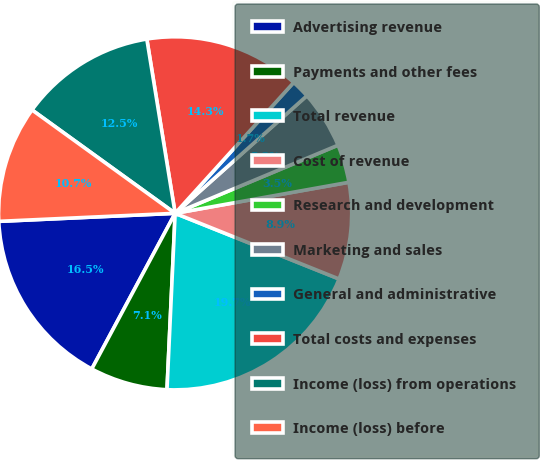<chart> <loc_0><loc_0><loc_500><loc_500><pie_chart><fcel>Advertising revenue<fcel>Payments and other fees<fcel>Total revenue<fcel>Cost of revenue<fcel>Research and development<fcel>Marketing and sales<fcel>General and administrative<fcel>Total costs and expenses<fcel>Income (loss) from operations<fcel>Income (loss) before<nl><fcel>16.45%<fcel>7.09%<fcel>19.67%<fcel>8.88%<fcel>3.49%<fcel>5.29%<fcel>1.69%<fcel>14.28%<fcel>12.48%<fcel>10.68%<nl></chart> 